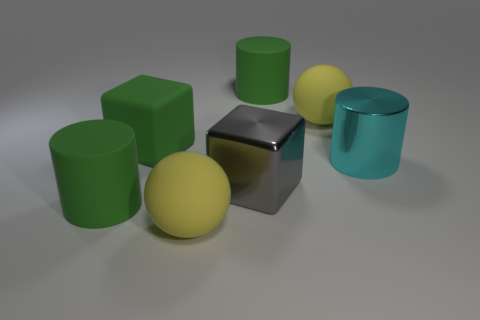Subtract all big cyan cylinders. How many cylinders are left? 2 Subtract 2 spheres. How many spheres are left? 0 Subtract all cyan cylinders. How many cylinders are left? 2 Add 3 tiny yellow metal blocks. How many objects exist? 10 Subtract all cylinders. How many objects are left? 4 Subtract all green rubber cylinders. Subtract all big green rubber blocks. How many objects are left? 4 Add 4 large green rubber cylinders. How many large green rubber cylinders are left? 6 Add 4 tiny shiny cylinders. How many tiny shiny cylinders exist? 4 Subtract 0 brown cylinders. How many objects are left? 7 Subtract all brown cubes. Subtract all red cylinders. How many cubes are left? 2 